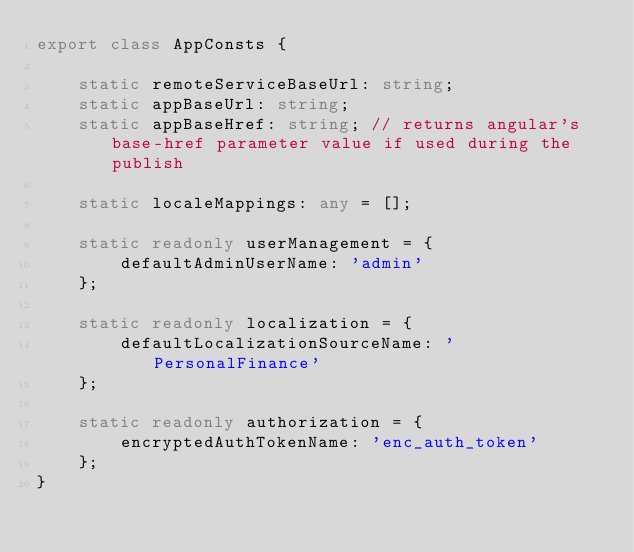Convert code to text. <code><loc_0><loc_0><loc_500><loc_500><_TypeScript_>export class AppConsts {

    static remoteServiceBaseUrl: string;
    static appBaseUrl: string;
    static appBaseHref: string; // returns angular's base-href parameter value if used during the publish

    static localeMappings: any = [];

    static readonly userManagement = {
        defaultAdminUserName: 'admin'
    };

    static readonly localization = {
        defaultLocalizationSourceName: 'PersonalFinance'
    };

    static readonly authorization = {
        encryptedAuthTokenName: 'enc_auth_token'
    };
}
</code> 